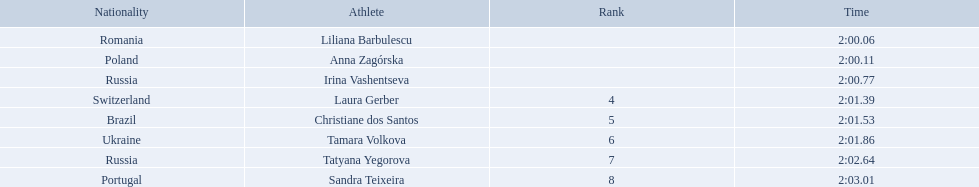Who came in second place at the athletics at the 2003 summer universiade - women's 800 metres? Anna Zagórska. What was her time? 2:00.11. 